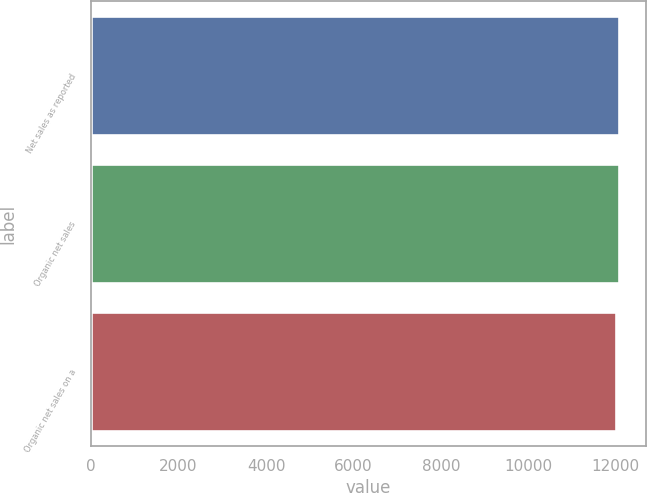Convert chart to OTSL. <chart><loc_0><loc_0><loc_500><loc_500><bar_chart><fcel>Net sales as reported<fcel>Organic net sales<fcel>Organic net sales on a<nl><fcel>12074.5<fcel>12081.6<fcel>12003<nl></chart> 